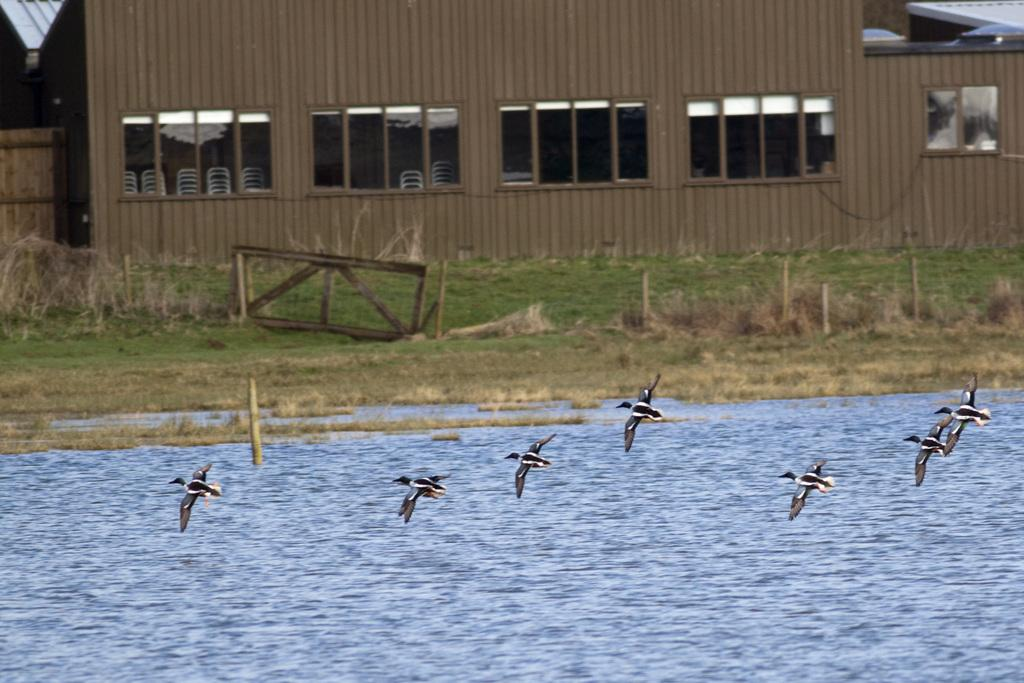What is happening in the image involving animals? There are birds flying in the image. What type of natural environment is visible in the image? Water and grass are visible in the image. What type of structure is present in the image? There is a wooden house in the image. What feature can be seen on the wooden house? The wooden house has windows. What type of religious symbol can be seen near the wooden house in the image? There is no religious symbol present near the wooden house in the image. How many fire trucks are visible in the image? There are no fire trucks present in the image. 